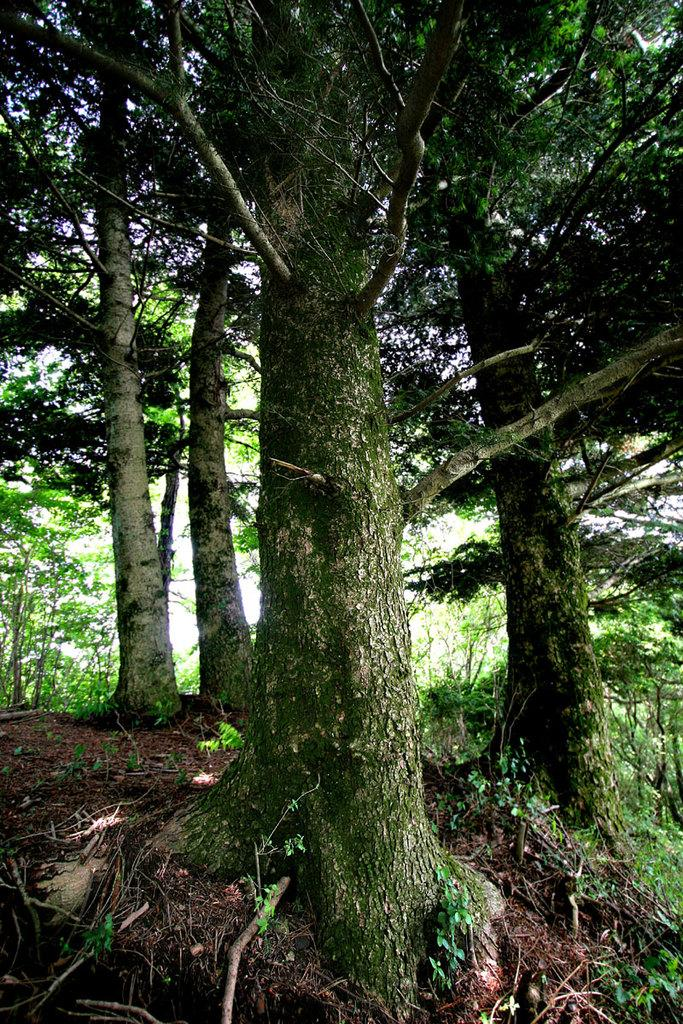What type of vegetation can be seen in the image? There are trees and plants in the image. Can you describe the plants in the image? The plants in the image are not specified, but they are present alongside the trees. What type of twig is being used as a vessel in the image? There is no twig or vessel present in the image; it only features trees and plants. 